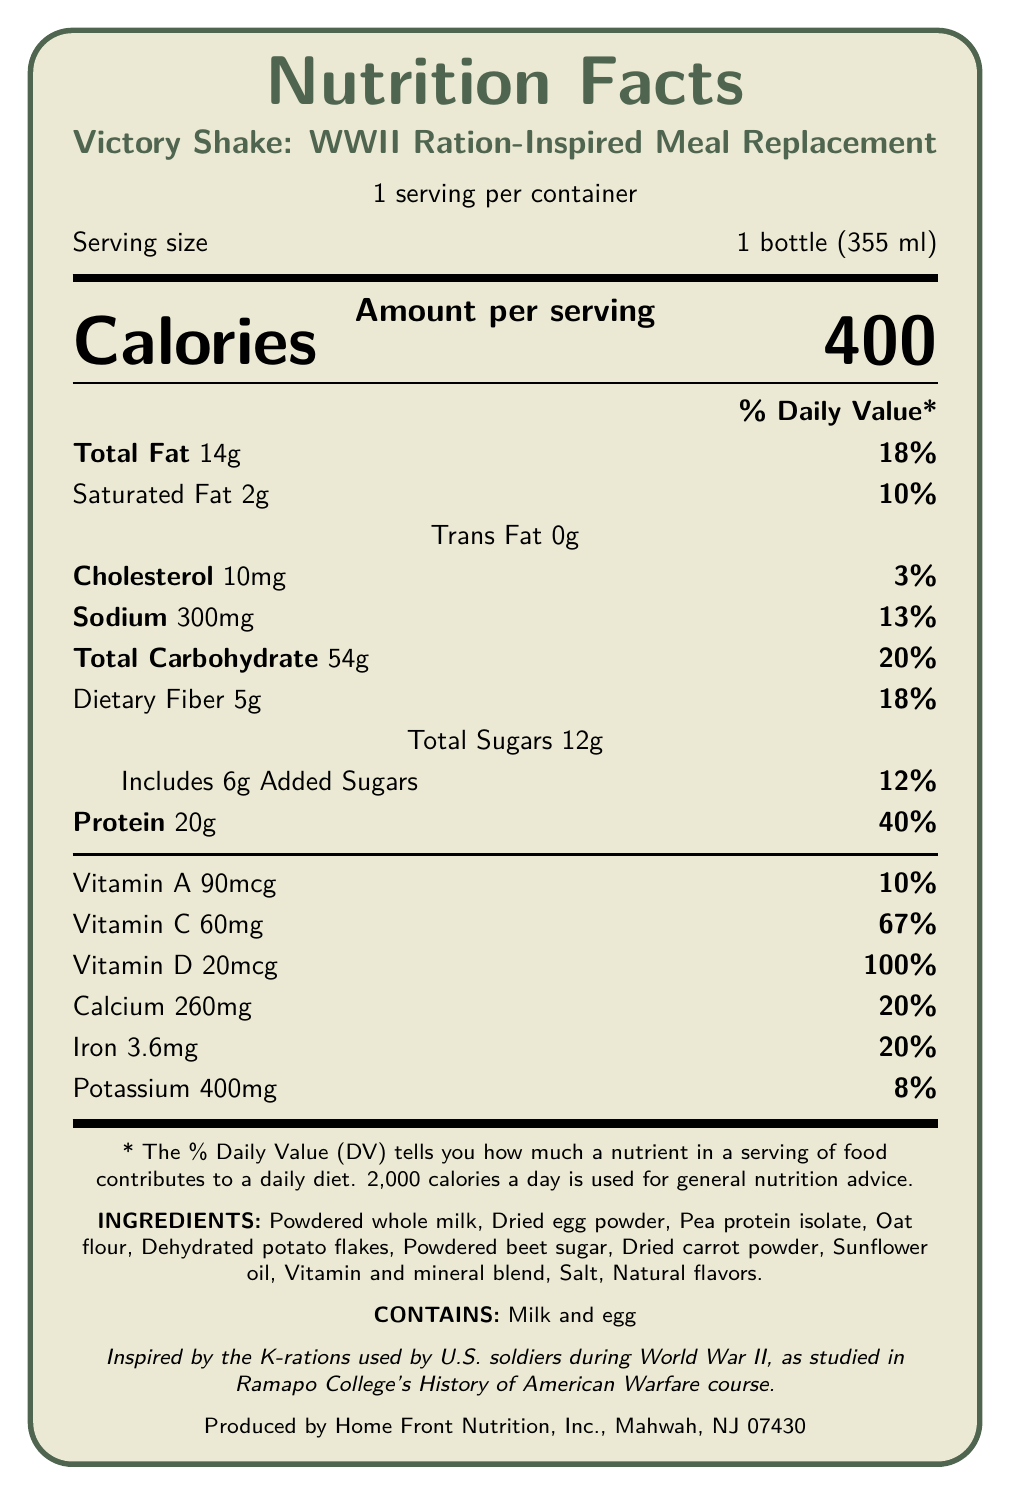what is the product name? The product name is clearly listed at the top and in the main section of the document.
Answer: Victory Shake: WWII Ration-Inspired Meal Replacement how many servings are in each container? The document states "1 serving per container" under the product name.
Answer: 1 what is the serving size? The serving size is displayed directly below the "1 serving per container" line as "Serving size 1 bottle (355 ml)".
Answer: 1 bottle (355 ml) how many calories are in one serving of the product? The number of calories per serving is prominently displayed in large font in the "Amount per serving" section.
Answer: 400 what percentage of daily value is the protein content? The daily value percentage for protein is listed next to the protein amount in grams.
Answer: 40% list three ingredients in the Victory Shake. The document provides all ingredients right after the nutritional information in the "INGREDIENTS" section.
Answer: Powdered whole milk, Dried egg powder, Pea protein isolate how much sodium does this product contain per serving? The sodium content is listed in the nutritional information section as 300 mg.
Answer: 300 mg what is the percentage of daily value for iron? The percentage of daily value for iron is specifically mentioned in the nutrient breakdown under the iron amount.
Answer: 20% which vitamin has the highest percentage of daily value? A. Vitamin A B. Vitamin C C. Vitamin D D. Calcium The document indicates that Vitamin D has a daily value of 100%, which is the highest among all listed vitamins and minerals.
Answer: C how many grams of total carbohydrates are in one serving? A. 20g B. 54g C. 14g D. 5g The document lists the total carbohydrate content as 54 grams, making option B correct.
Answer: B does the product contain any allergens? The allergen information, "Contains milk and egg," is listed in the ingredients section.
Answer: Yes is the product inspired by the K-rations used by U.S. soldiers during World War II? The historical context provided in the document states that it is inspired by the K-rations used by U.S. soldiers during WWII.
Answer: Yes describe the main idea of the document. This document is a comprehensive Nutrition Facts Label for "Victory Shake: WWII Ration-Inspired Meal Replacement" including nutritional details, ingredients, allergens, historical inspiration, and manufacturer info.
Answer: The document provides detailed nutritional information for the "Victory Shake: WWII Ration-Inspired Meal Replacement." It includes calories, nutrient amounts, daily values, ingredients, allergen information, historical inspiration, and manufacturer details. what is the manufacturer's location? The document states that the product is produced by Home Front Nutrition, Inc., Mahwah, NJ 07430.
Answer: Mahwah, NJ 07430 what is the amount of added sugars? The amount of added sugars is 6g as listed under the total sugars in the nutritional information.
Answer: 6g how many grams of dietary fiber are in one serving? The amount of dietary fiber per serving is documented as 5 grams in the nutrient information.
Answer: 5g what is the historical context of the Victory Shake product? The historical context is described just below the main nutritional breakdown and states that the product is inspired by WWII K-rations.
Answer: Inspired by the K-rations used by U.S. soldiers during World War II, as studied in Ramapo College's History of American Warfare course. which university course is linked to the historical inspiration for this product? This information is explicitly given in the "historicalContext" section of the document.
Answer: Ramapo College's History of American Warfare course what is the amount of vitamin A per serving? The amount of vitamin A is listed as 90 mcg in the vitamins and minerals section.
Answer: 90 mcg how many calories come from fat in this product? The document does not provide specific information on the calories coming from fat alone, only the total calories and fat grams.
Answer: Cannot be determined 